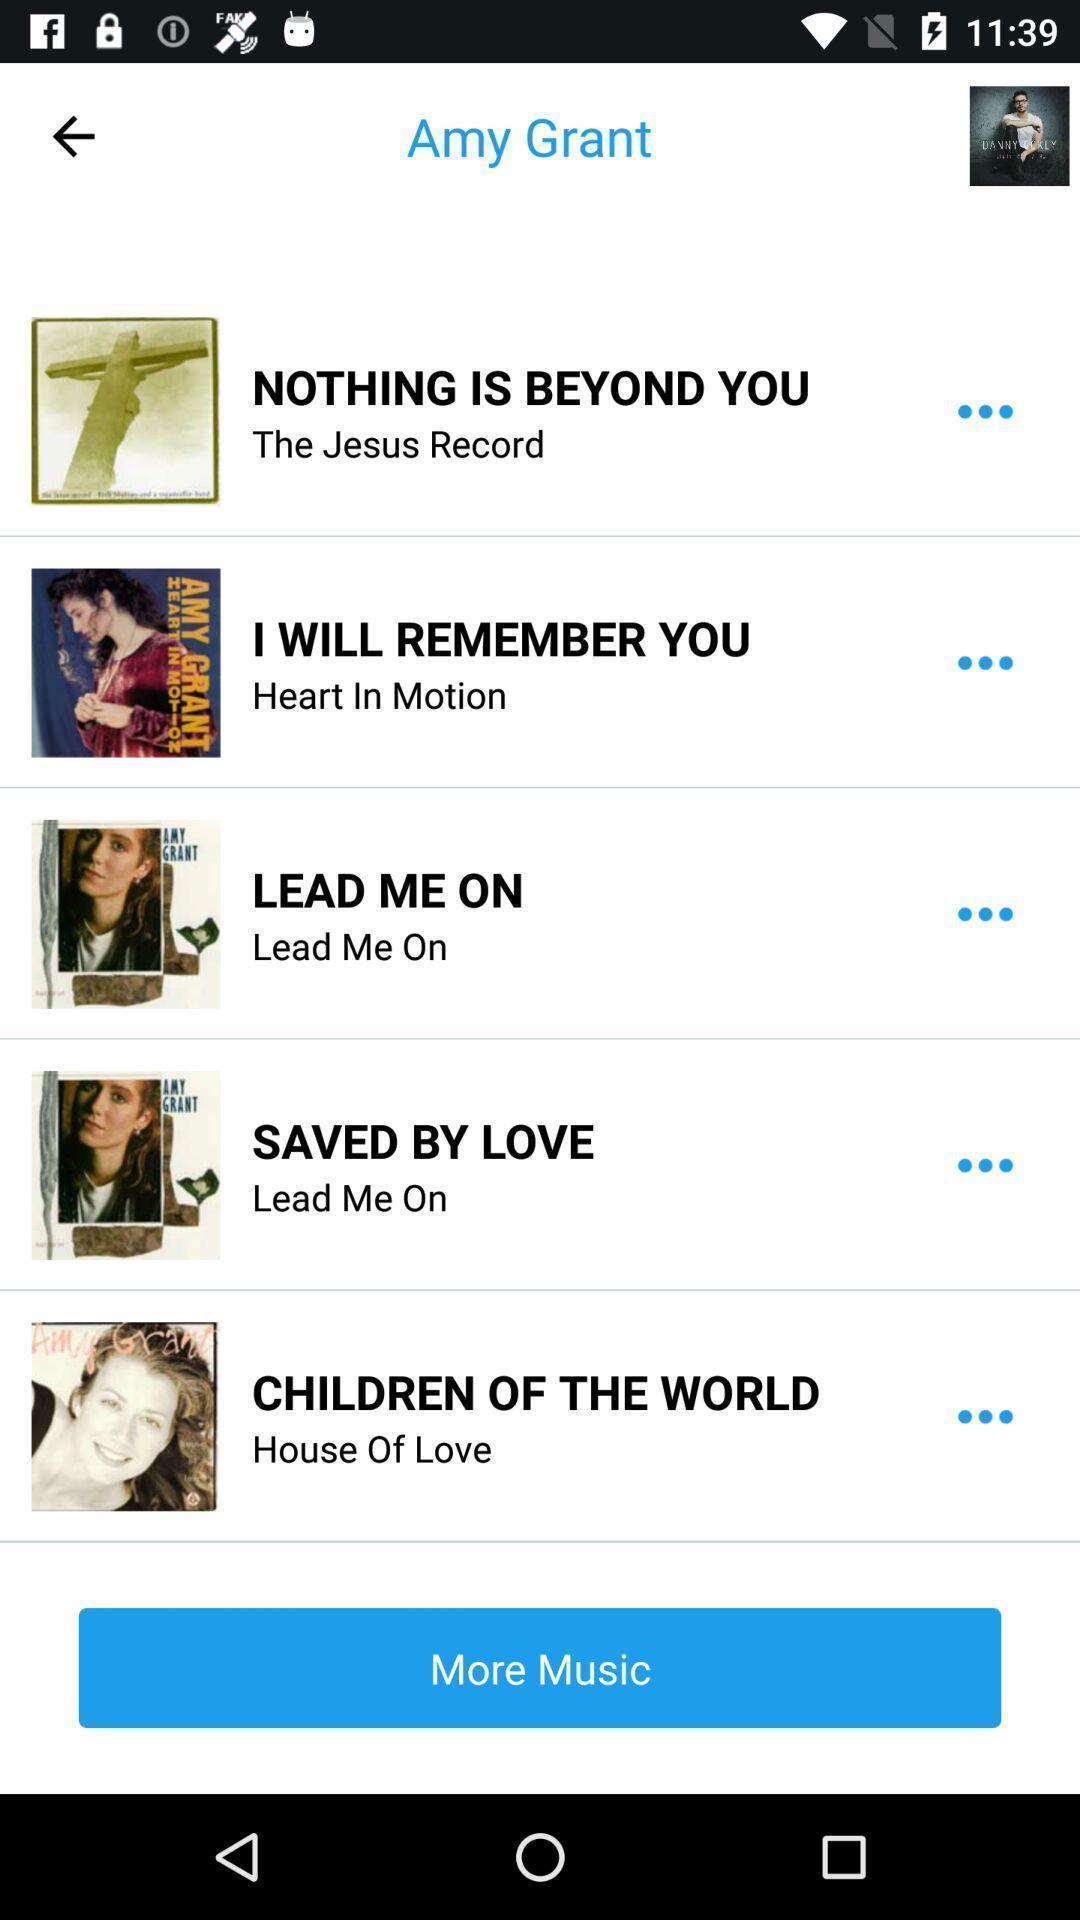Give me a narrative description of this picture. Screen displaying more music option. 